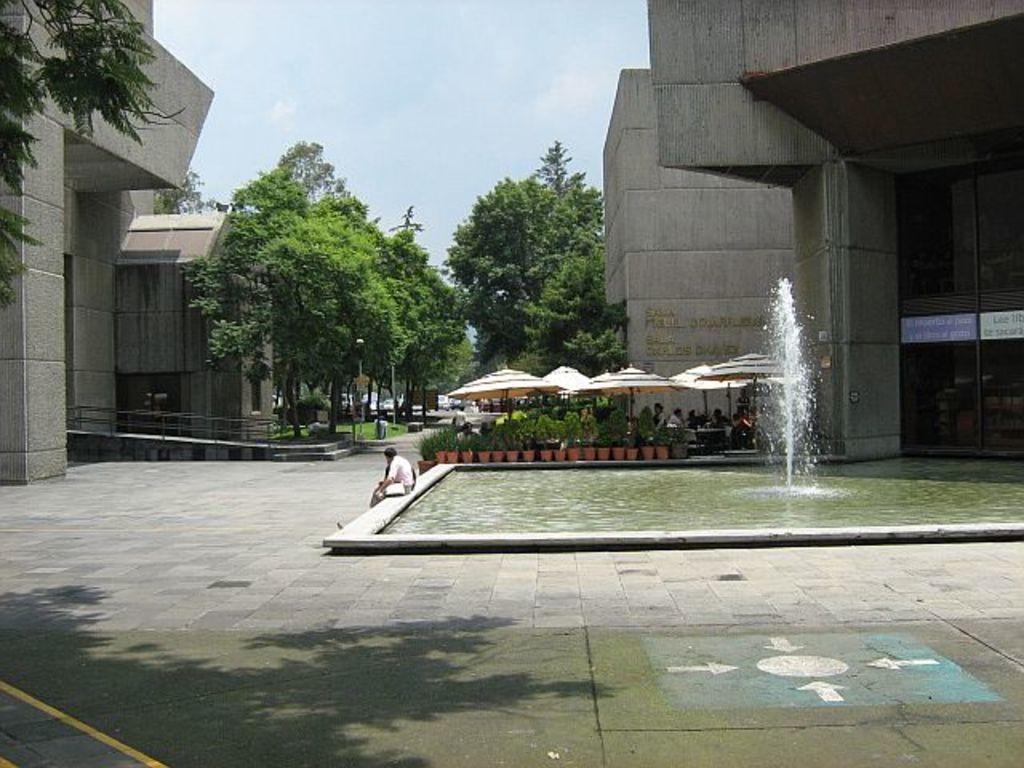What is the primary element visible in the image? There is water in the image. What objects can be seen in the water? There are boards in the image. What type of vegetation is present in the image? There are plants in the image. Who or what is in the image along with the water, boards, and plants? There are persons in the image. What can be seen in the background of the image? There are trees, buildings, and the sky visible in the background of the image. How many dimes are visible on the ground in the image? There are no dimes visible on the ground in the image. What is the relationship between the persons in the image and their brothers? The provided facts do not mention any brothers, so we cannot determine their relationship. 